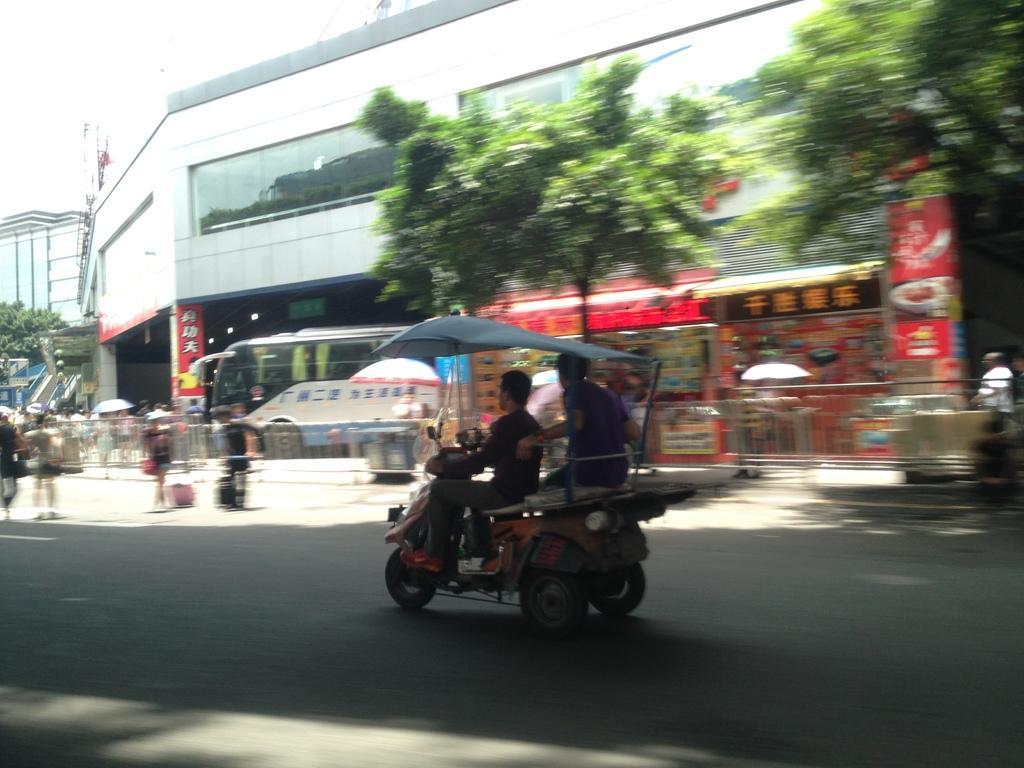Describe this image in one or two sentences. Two persons are riding in the vehicle on the road,there are big buildings,trees,vehicles and few people on the road. 